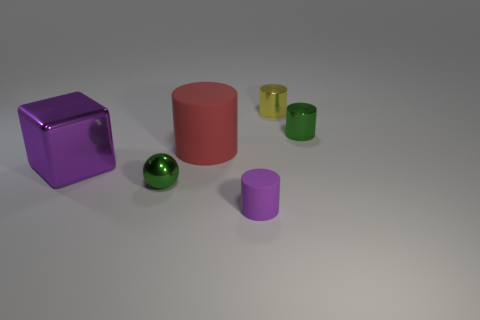Add 4 tiny things. How many objects exist? 10 Subtract all purple cylinders. How many cylinders are left? 3 Subtract all yellow cylinders. How many cylinders are left? 3 Subtract all cubes. How many objects are left? 5 Subtract all brown cylinders. Subtract all purple balls. How many cylinders are left? 4 Subtract all yellow cubes. How many yellow spheres are left? 0 Subtract all yellow shiny cylinders. Subtract all small cylinders. How many objects are left? 2 Add 5 rubber cylinders. How many rubber cylinders are left? 7 Add 3 green balls. How many green balls exist? 4 Subtract 1 yellow cylinders. How many objects are left? 5 